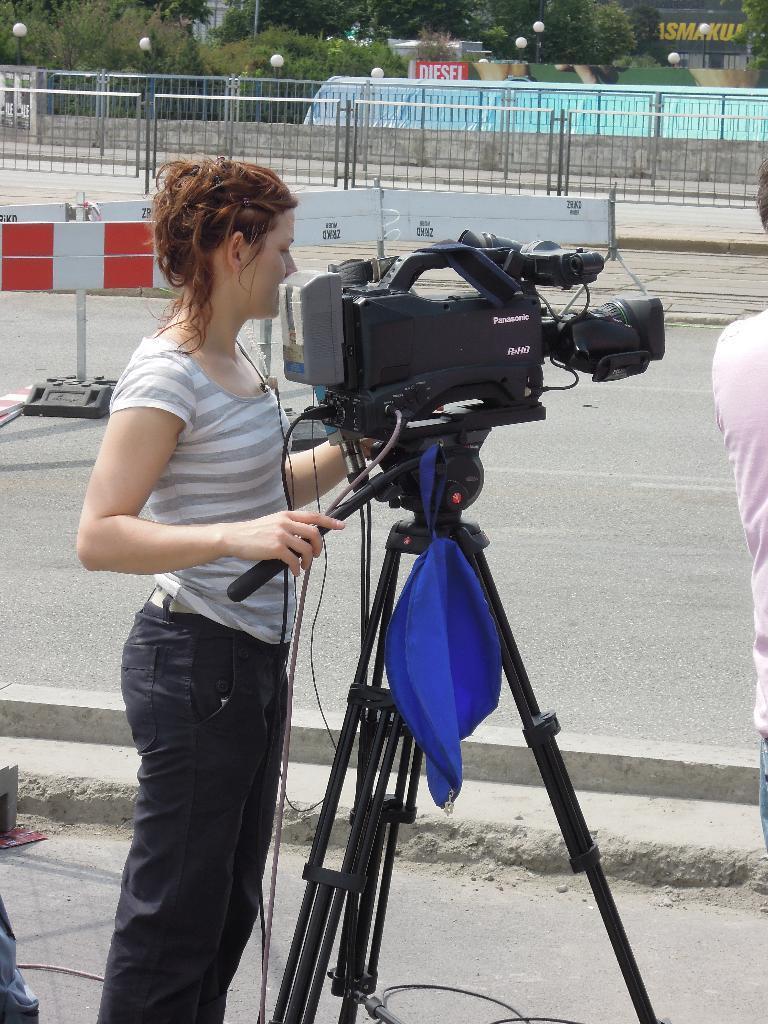Can you describe this image briefly? This is the woman standing. I can see a video recorder with a tripod stand. This looks like a bag, which is blue in color. These are the barricades. In the background, I can see the trees, street lights and buildings. These look like the boards. At the right corner of the image, I can see a person standing. 